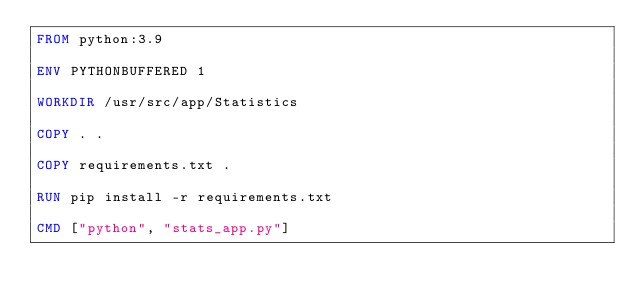<code> <loc_0><loc_0><loc_500><loc_500><_Dockerfile_>FROM python:3.9

ENV PYTHONBUFFERED 1

WORKDIR /usr/src/app/Statistics

COPY . .

COPY requirements.txt .

RUN pip install -r requirements.txt

CMD ["python", "stats_app.py"]</code> 